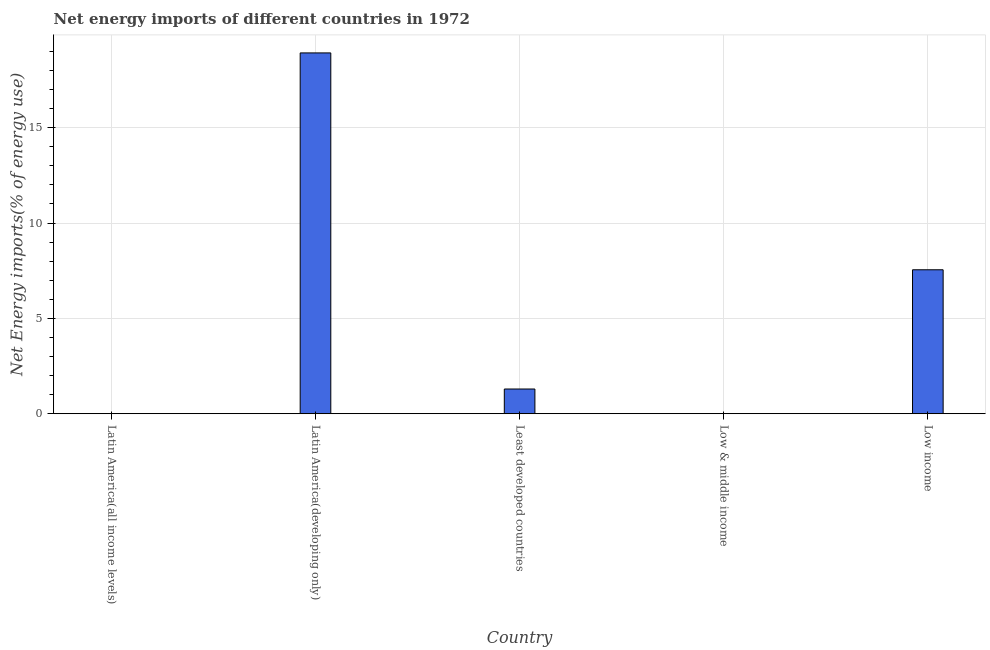Does the graph contain any zero values?
Your response must be concise. Yes. What is the title of the graph?
Provide a succinct answer. Net energy imports of different countries in 1972. What is the label or title of the Y-axis?
Offer a terse response. Net Energy imports(% of energy use). What is the energy imports in Least developed countries?
Provide a short and direct response. 1.3. Across all countries, what is the maximum energy imports?
Provide a succinct answer. 18.92. Across all countries, what is the minimum energy imports?
Your answer should be very brief. 0. In which country was the energy imports maximum?
Provide a short and direct response. Latin America(developing only). What is the sum of the energy imports?
Ensure brevity in your answer.  27.76. What is the difference between the energy imports in Least developed countries and Low income?
Keep it short and to the point. -6.25. What is the average energy imports per country?
Your response must be concise. 5.55. What is the median energy imports?
Ensure brevity in your answer.  1.3. In how many countries, is the energy imports greater than 2 %?
Offer a very short reply. 2. What is the ratio of the energy imports in Latin America(developing only) to that in Low income?
Offer a terse response. 2.51. What is the difference between the highest and the second highest energy imports?
Your answer should be very brief. 11.37. Is the sum of the energy imports in Latin America(developing only) and Low income greater than the maximum energy imports across all countries?
Make the answer very short. Yes. What is the difference between the highest and the lowest energy imports?
Your answer should be compact. 18.92. How many bars are there?
Provide a succinct answer. 3. Are all the bars in the graph horizontal?
Your answer should be very brief. No. How many countries are there in the graph?
Provide a short and direct response. 5. What is the Net Energy imports(% of energy use) of Latin America(all income levels)?
Make the answer very short. 0. What is the Net Energy imports(% of energy use) of Latin America(developing only)?
Your response must be concise. 18.92. What is the Net Energy imports(% of energy use) in Least developed countries?
Provide a short and direct response. 1.3. What is the Net Energy imports(% of energy use) in Low & middle income?
Your answer should be compact. 0. What is the Net Energy imports(% of energy use) in Low income?
Keep it short and to the point. 7.55. What is the difference between the Net Energy imports(% of energy use) in Latin America(developing only) and Least developed countries?
Keep it short and to the point. 17.62. What is the difference between the Net Energy imports(% of energy use) in Latin America(developing only) and Low income?
Offer a very short reply. 11.37. What is the difference between the Net Energy imports(% of energy use) in Least developed countries and Low income?
Offer a terse response. -6.25. What is the ratio of the Net Energy imports(% of energy use) in Latin America(developing only) to that in Least developed countries?
Offer a very short reply. 14.59. What is the ratio of the Net Energy imports(% of energy use) in Latin America(developing only) to that in Low income?
Keep it short and to the point. 2.51. What is the ratio of the Net Energy imports(% of energy use) in Least developed countries to that in Low income?
Offer a terse response. 0.17. 